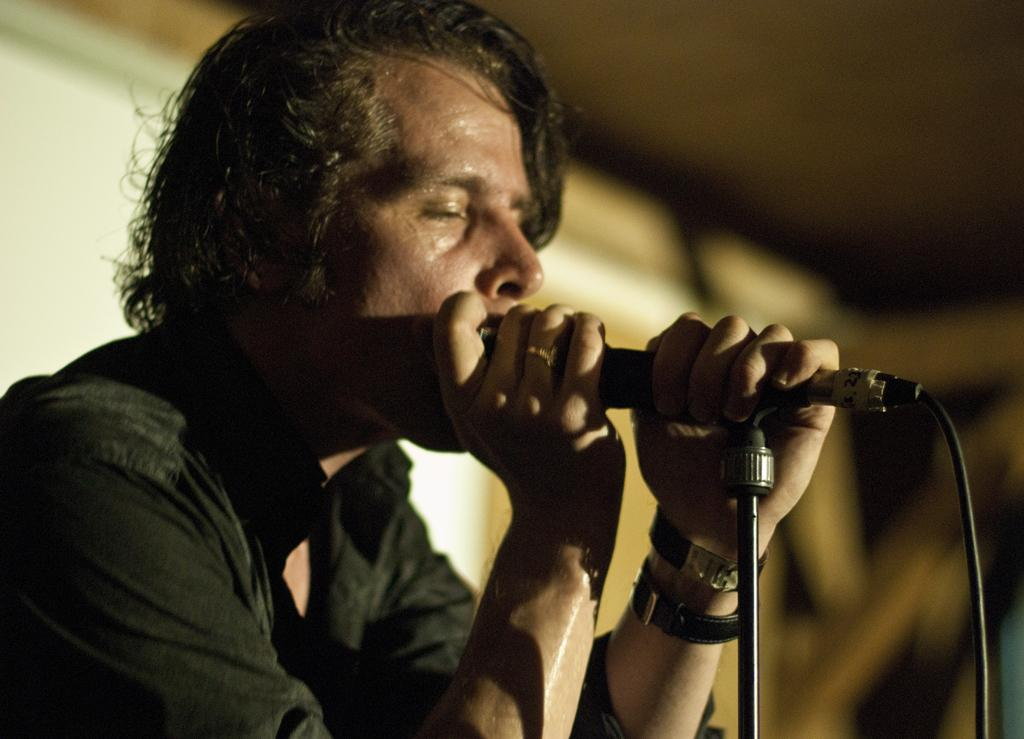Who is the main subject in the image? There is a man in the image. What is the man holding in the image? The man is holding a microphone. Can you describe the background of the image? The background of the image is blurred. What type of glove is the man wearing in the image? There is no glove present in the image; the man is holding a microphone. What date is marked on the calendar in the image? There is no calendar present in the image. 